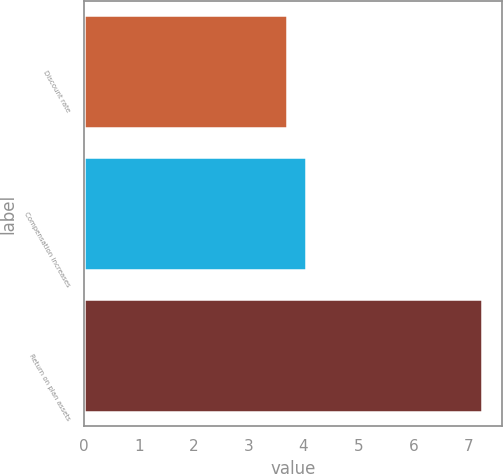<chart> <loc_0><loc_0><loc_500><loc_500><bar_chart><fcel>Discount rate<fcel>Compensation increases<fcel>Return on plan assets<nl><fcel>3.7<fcel>4.05<fcel>7.25<nl></chart> 